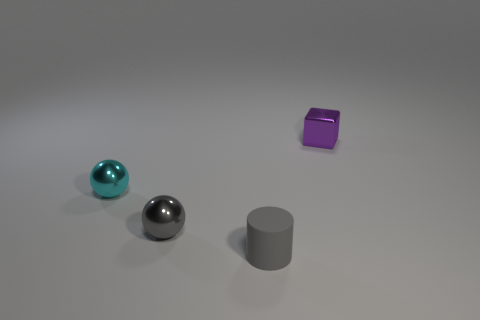There is a tiny cylinder; is its color the same as the small metallic sphere that is in front of the cyan shiny thing?
Provide a short and direct response. Yes. How many other objects are there of the same size as the purple metal object?
Ensure brevity in your answer.  3. There is a object that is the same color as the cylinder; what is its size?
Keep it short and to the point. Small. What number of spheres are either large objects or small metallic objects?
Make the answer very short. 2. There is a small gray object on the left side of the tiny gray rubber thing; does it have the same shape as the small cyan metallic object?
Give a very brief answer. Yes. Are there more small metallic things that are in front of the tiny purple shiny block than tiny purple shiny things?
Make the answer very short. Yes. What is the color of the shiny ball that is the same size as the gray metallic object?
Your response must be concise. Cyan. How many objects are either small balls on the left side of the matte thing or large purple objects?
Your answer should be very brief. 2. What shape is the metallic thing that is the same color as the small cylinder?
Ensure brevity in your answer.  Sphere. There is a tiny gray cylinder that is in front of the ball that is behind the gray ball; what is it made of?
Make the answer very short. Rubber. 